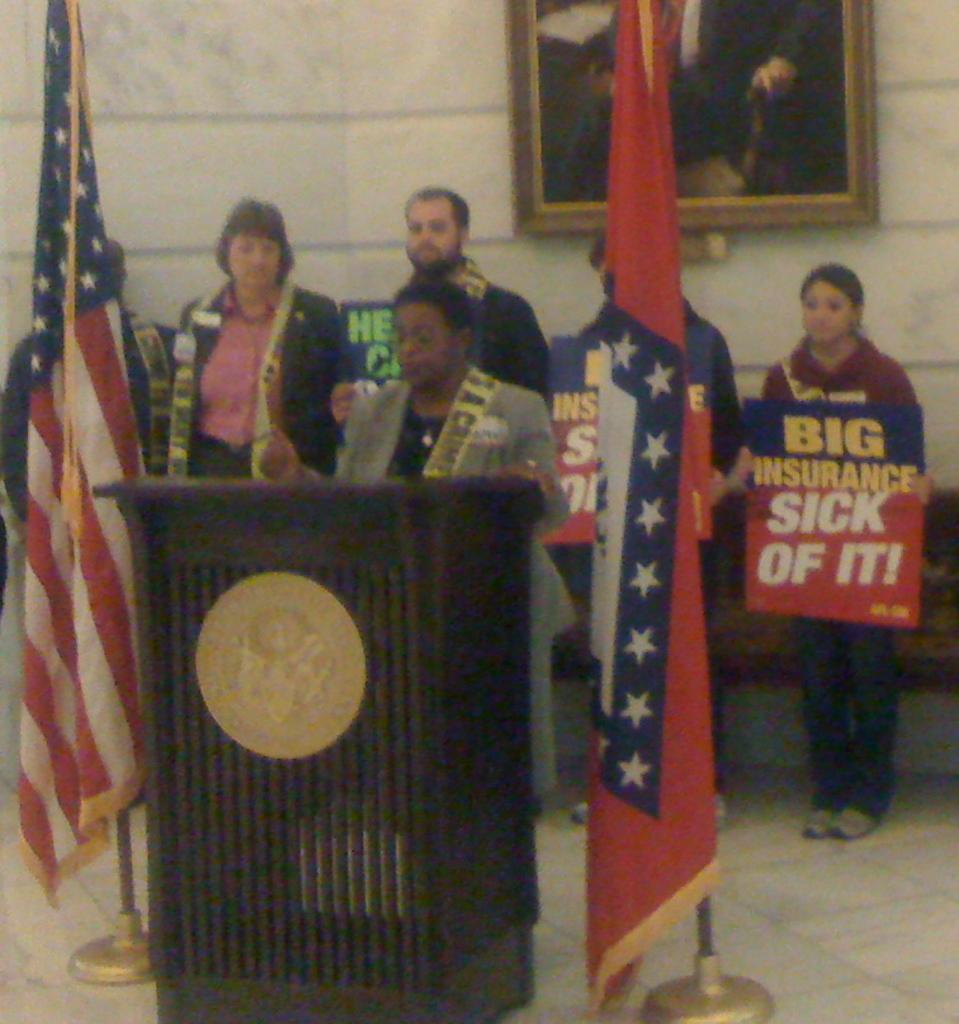Provide a one-sentence caption for the provided image. A black woman stands at a podium with an American flag next to her while a woman behind her holds a sign that reads "Big Insurance, Sick of It!". 